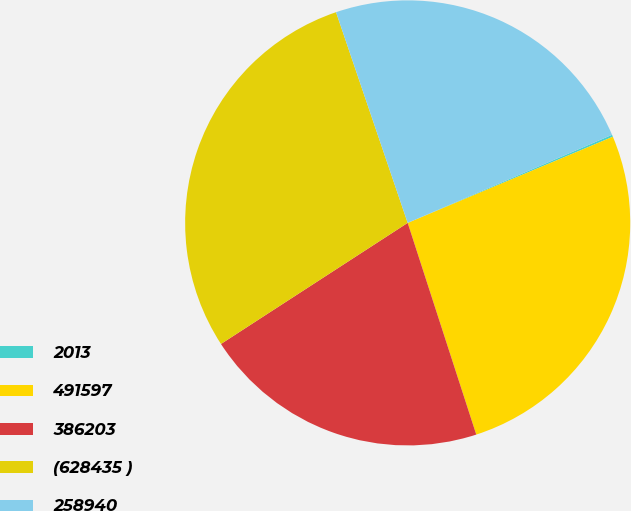Convert chart to OTSL. <chart><loc_0><loc_0><loc_500><loc_500><pie_chart><fcel>2013<fcel>491597<fcel>386203<fcel>(628435 )<fcel>258940<nl><fcel>0.15%<fcel>26.34%<fcel>20.83%<fcel>28.94%<fcel>23.74%<nl></chart> 